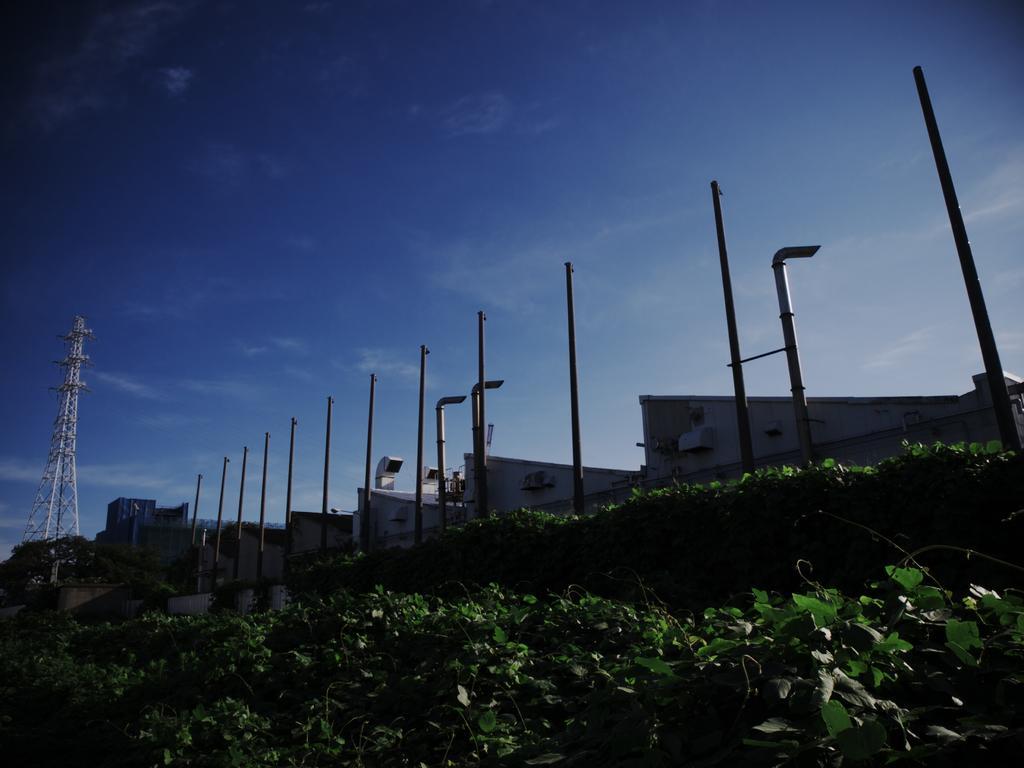How would you summarize this image in a sentence or two? At the bottom there are plants, in the middle there are iron rods and exhaust pipes. On the left side there is a tower, at the top it is the sky. 